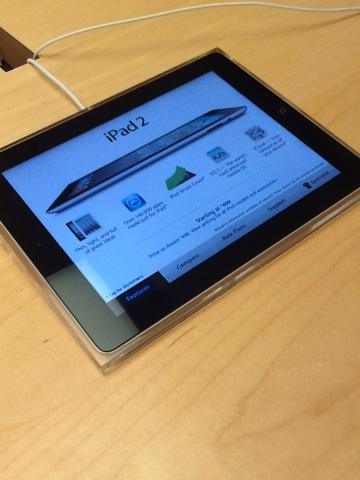How has the iPad changed since this version? Since the iPad 2, Apple has introduced several new models, each featuring significant upgrades such as higher resolution 'Retina' displays, more powerful processors, improved cameras, and lighter designs. New functionalities like fingerprint scanning and facial recognition have also been added in later models. What are the uses of an iPad in today's digital age? iPads are used widely today for educational purposes, personal entertainment, professional productivity, and creative projects. They serve as e-readers, portable media players, and lightweight alternatives to laptops. Enhanced connectivity options with other devices have also made them central in smart home setups and business operations. 